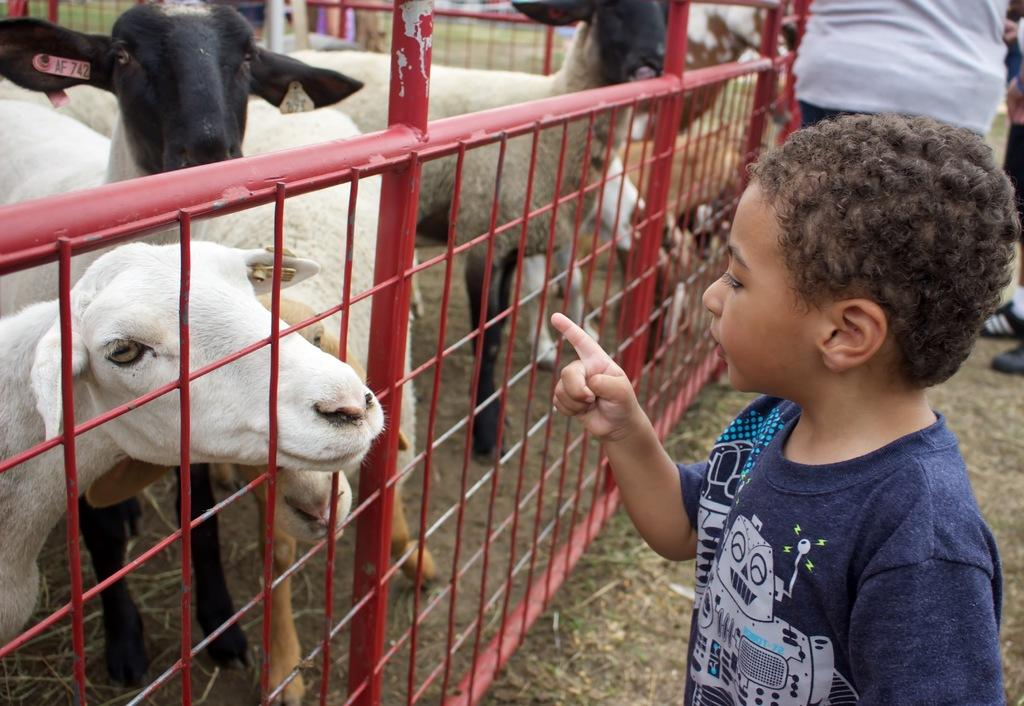What animals are present in the image? There is a herd of sheep in the image. What is the kid in the image doing? The kid is standing and pointing at the sheep. Are there any other people visible in the image? Yes, there are other people standing in the background. What type of tree can be seen in the image? There is no tree present in the image; it features a herd of sheep and people. What ingredients are used to make the stew in the image? There is no stew present in the image; it features a herd of sheep and people. 